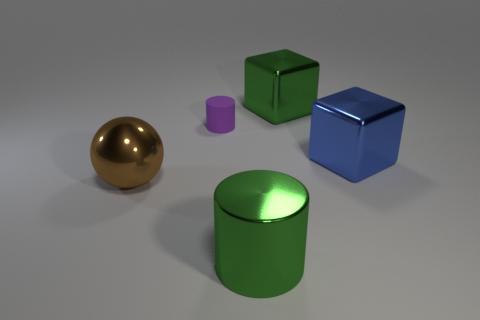The other large metallic thing that is the same shape as the large blue metal object is what color? green 